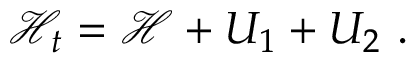Convert formula to latex. <formula><loc_0><loc_0><loc_500><loc_500>\mathcal { H } _ { t } = \mathcal { H } + U _ { 1 } + U _ { 2 } \ .</formula> 